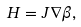<formula> <loc_0><loc_0><loc_500><loc_500>H = J \nabla \beta ,</formula> 